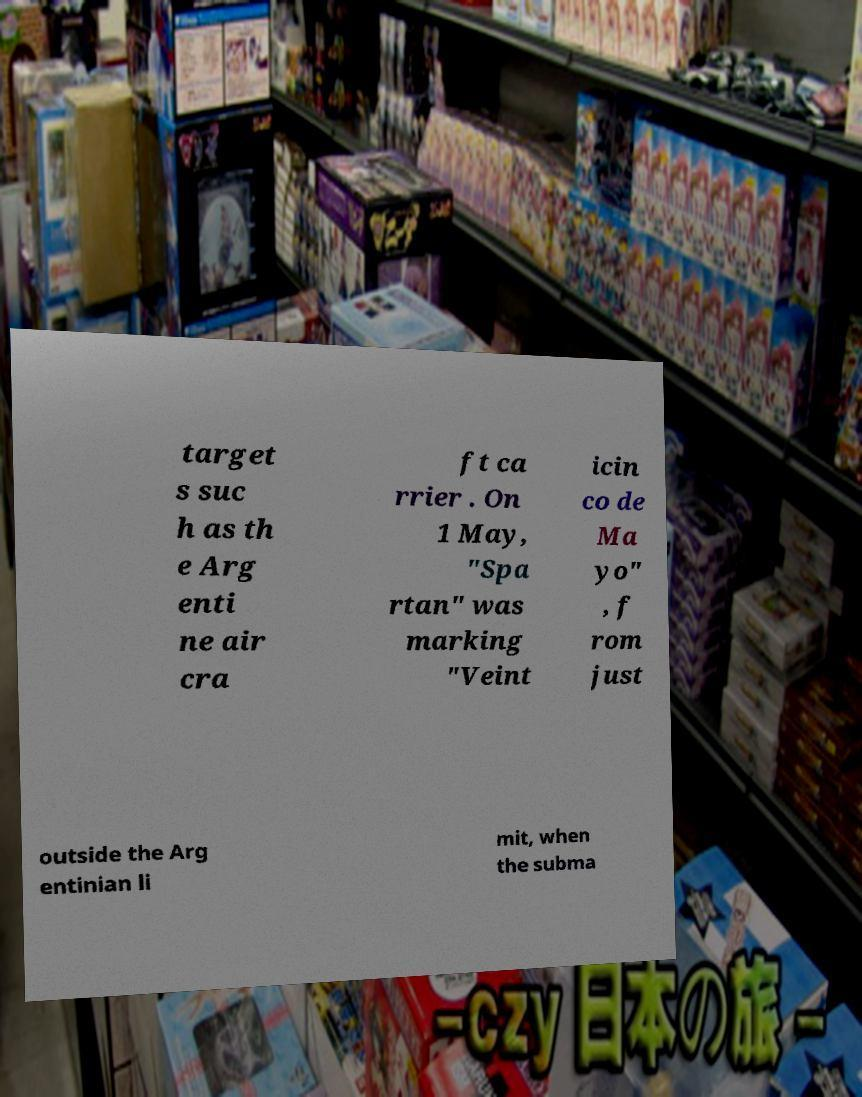Could you extract and type out the text from this image? target s suc h as th e Arg enti ne air cra ft ca rrier . On 1 May, "Spa rtan" was marking "Veint icin co de Ma yo" , f rom just outside the Arg entinian li mit, when the subma 